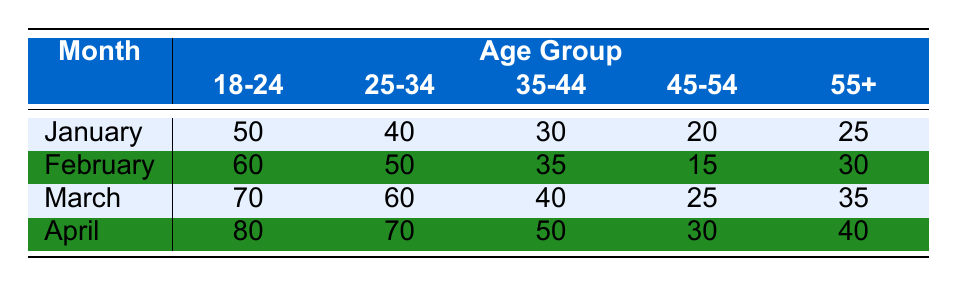What was the attendance for the 25-34 age group in March? The table lists the attendance for each age group in each month. For March, the attendance for the 25-34 age group is directly specified in the table as 60.
Answer: 60 Which month had the highest attendance for the 18-24 age group? Looking at the table, the attendance for the 18-24 age group for each month is 50 in January, 60 in February, 70 in March, and 80 in April. The highest value is 80 in April.
Answer: April What is the total attendance for the 55+ age group from January to April? The attendance for the 55+ age group in each month is 25 in January, 30 in February, 35 in March, and 40 in April. Adding these values gives (25 + 30 + 35 + 40) = 130.
Answer: 130 Is the attendance for the 45-54 age group higher in February than in January? The table shows the attendance for the 45-54 age group as 20 in January and 15 in February. Since 20 is greater than 15, the attendance in February is lower.
Answer: No What age group had the least attendance in January? In January, the attendances are 50 for 18-24, 40 for 25-34, 30 for 35-44, 20 for 45-54, and 25 for 55+. The least attendance is 20 for the 45-54 age group.
Answer: 45-54 What is the average attendance for the 25-34 age group across all four months? The total attendance for the 25-34 age group is 40 (January) + 50 (February) + 60 (March) + 70 (April) = 220. Since there are 4 months, the average is 220 / 4 = 55.
Answer: 55 Was the attendance for the 35-44 age group consistent across the months? The attendance figures for the 35-44 age group are 30 in January, 35 in February, 40 in March, and 50 in April. Since these values are increasing, attendance was not consistent.
Answer: No Which month had the greatest increase in attendance for the 18-24 age group compared to the previous month? The attendance for the 18-24 age group is as follows: January (50), February (60), March (70), April (80). The increases are 10 (January to February), 10 (February to March), and 10 (March to April). Therefore, the increase was consistent across all months.
Answer: No increase greater than 10 How does the attendance for the 55+ age group compare to that of the 35-44 age group in April? In April, the attendance for the 55+ age group is 40 and for the 35-44 age group, it is 50. Since 40 is less than 50, the 55+ age group had lower attendance than the 35-44 age group in April.
Answer: Lower 